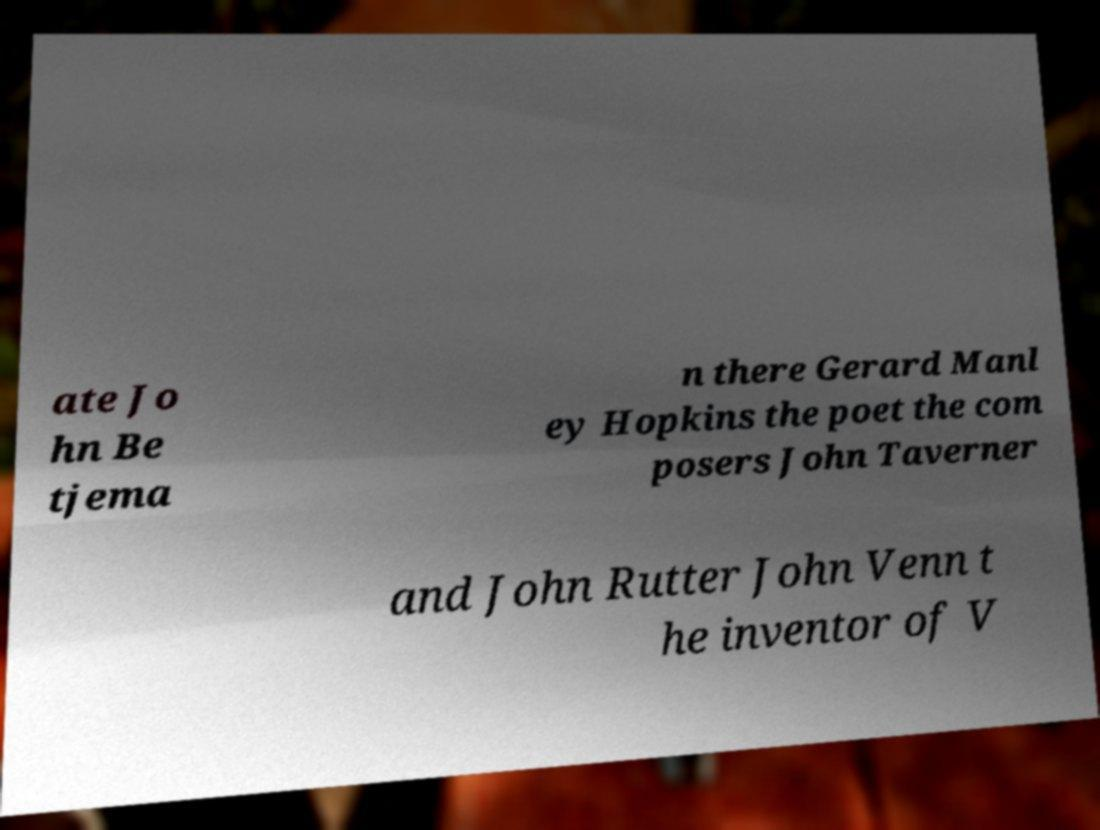Can you read and provide the text displayed in the image?This photo seems to have some interesting text. Can you extract and type it out for me? ate Jo hn Be tjema n there Gerard Manl ey Hopkins the poet the com posers John Taverner and John Rutter John Venn t he inventor of V 